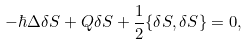<formula> <loc_0><loc_0><loc_500><loc_500>- \hbar { \Delta } \delta S + Q \delta S + \frac { 1 } { 2 } \{ \delta S , \delta S \} = 0 ,</formula> 